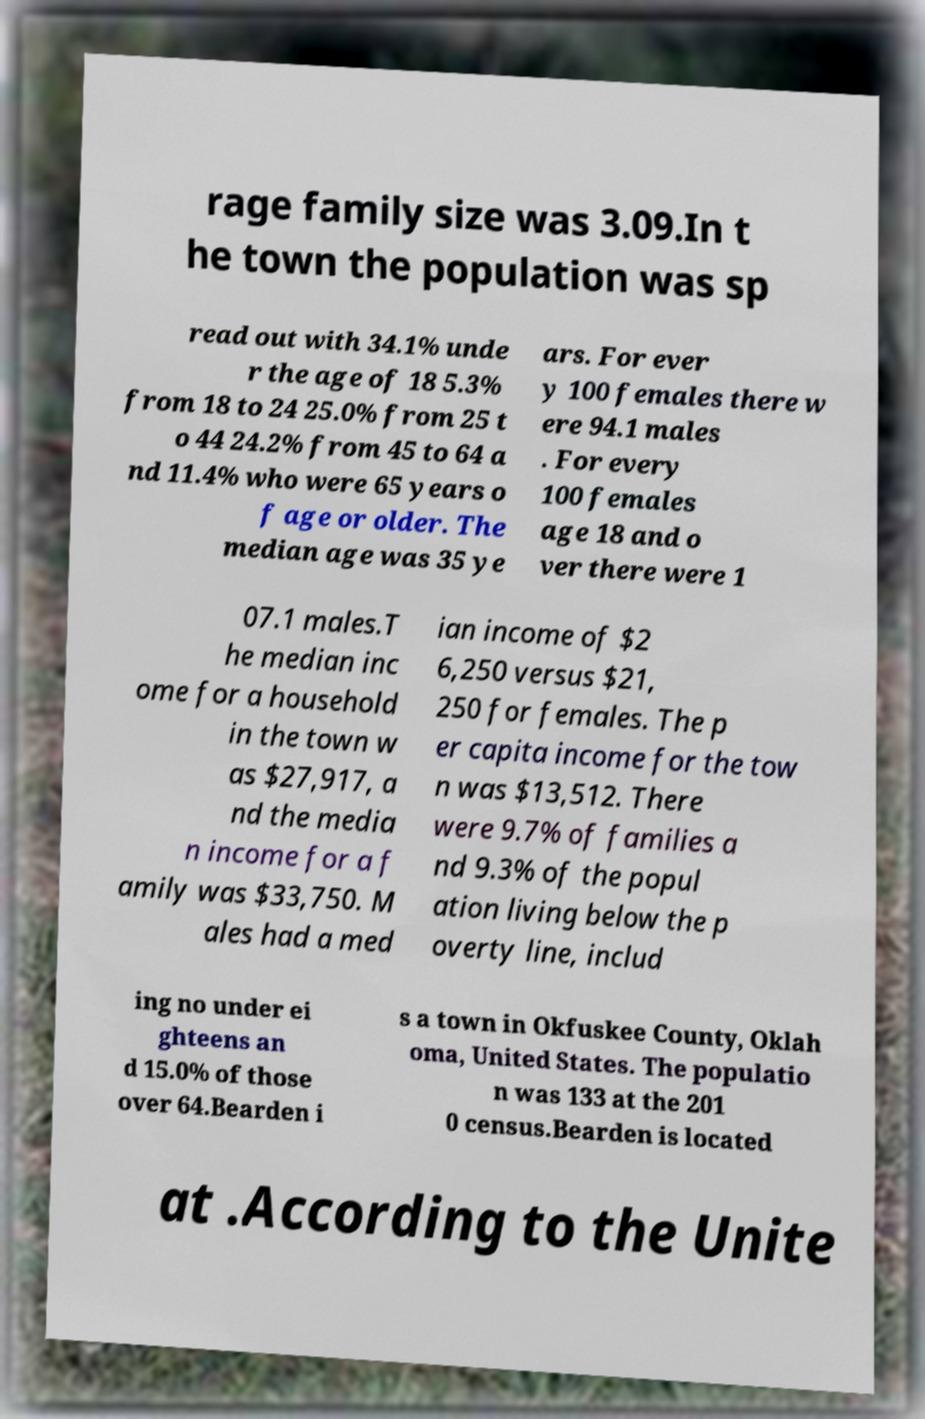Please read and relay the text visible in this image. What does it say? rage family size was 3.09.In t he town the population was sp read out with 34.1% unde r the age of 18 5.3% from 18 to 24 25.0% from 25 t o 44 24.2% from 45 to 64 a nd 11.4% who were 65 years o f age or older. The median age was 35 ye ars. For ever y 100 females there w ere 94.1 males . For every 100 females age 18 and o ver there were 1 07.1 males.T he median inc ome for a household in the town w as $27,917, a nd the media n income for a f amily was $33,750. M ales had a med ian income of $2 6,250 versus $21, 250 for females. The p er capita income for the tow n was $13,512. There were 9.7% of families a nd 9.3% of the popul ation living below the p overty line, includ ing no under ei ghteens an d 15.0% of those over 64.Bearden i s a town in Okfuskee County, Oklah oma, United States. The populatio n was 133 at the 201 0 census.Bearden is located at .According to the Unite 